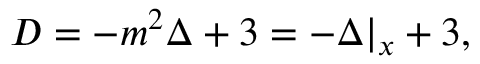<formula> <loc_0><loc_0><loc_500><loc_500>D = - m ^ { 2 } \Delta + 3 = - \Delta | _ { x } + 3 ,</formula> 